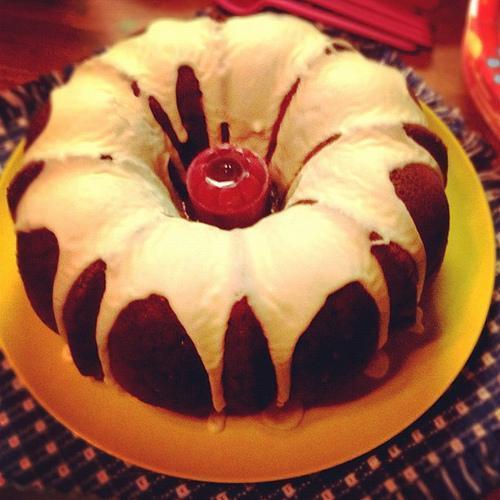How many cakes are on the table?
Give a very brief answer. 1. 